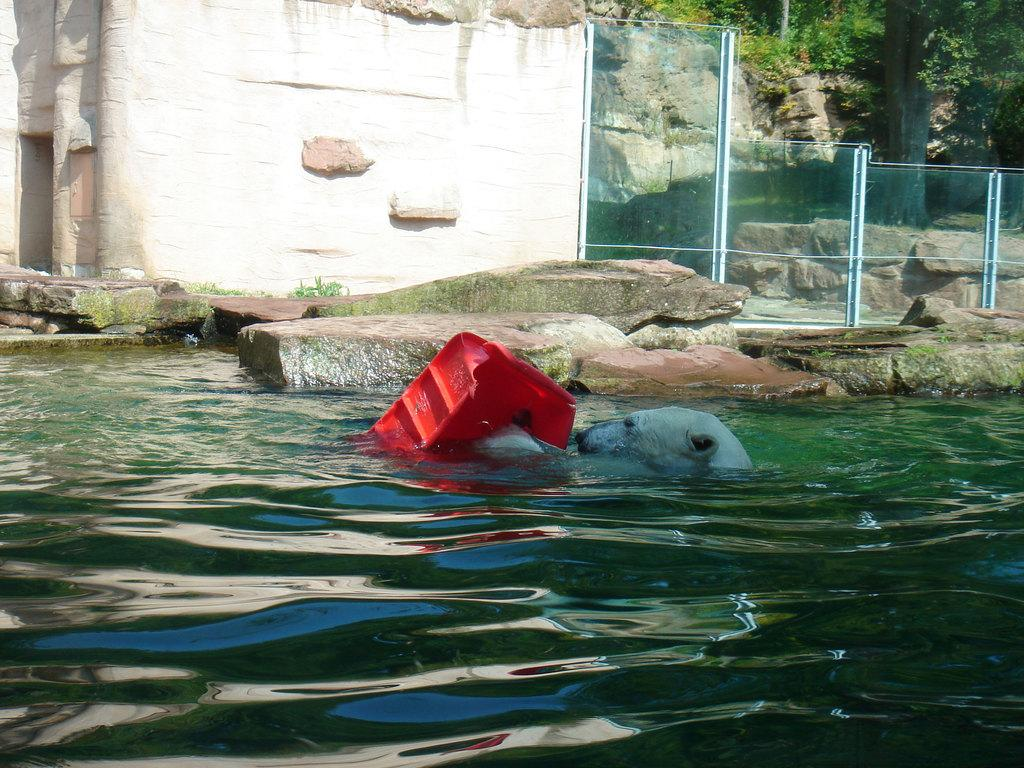What animal can be seen in the image? There is a dog in the image. Where is the dog located? The dog is in the water. What color is the object in the water? There is a red color object in the water. What can be seen in the background of the image? There is a fence, a monument, and trees in the background of the image. What type of wire is the dog using to prepare breakfast in the image? There is no wire or breakfast preparation in the image; it features a dog in the water with a red object nearby. 